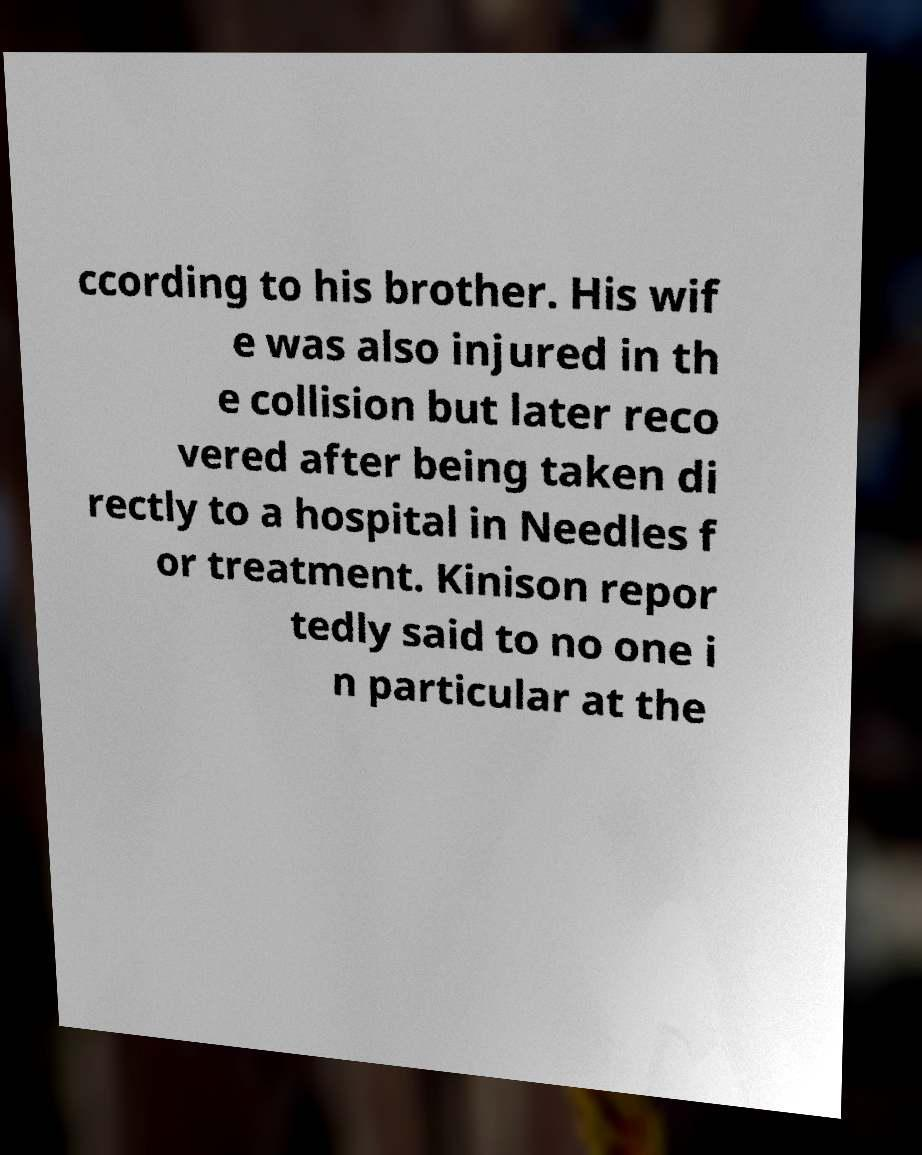Can you accurately transcribe the text from the provided image for me? ccording to his brother. His wif e was also injured in th e collision but later reco vered after being taken di rectly to a hospital in Needles f or treatment. Kinison repor tedly said to no one i n particular at the 